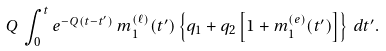<formula> <loc_0><loc_0><loc_500><loc_500>Q \, \int _ { 0 } ^ { t } e ^ { - Q ( t - t ^ { \prime } ) } \, m _ { 1 } ^ { ( \ell ) } ( t ^ { \prime } ) \left \{ q _ { 1 } + q _ { 2 } \left [ 1 + m _ { 1 } ^ { ( e ) } ( t ^ { \prime } ) \right ] \right \} \, d t ^ { \prime } .</formula> 